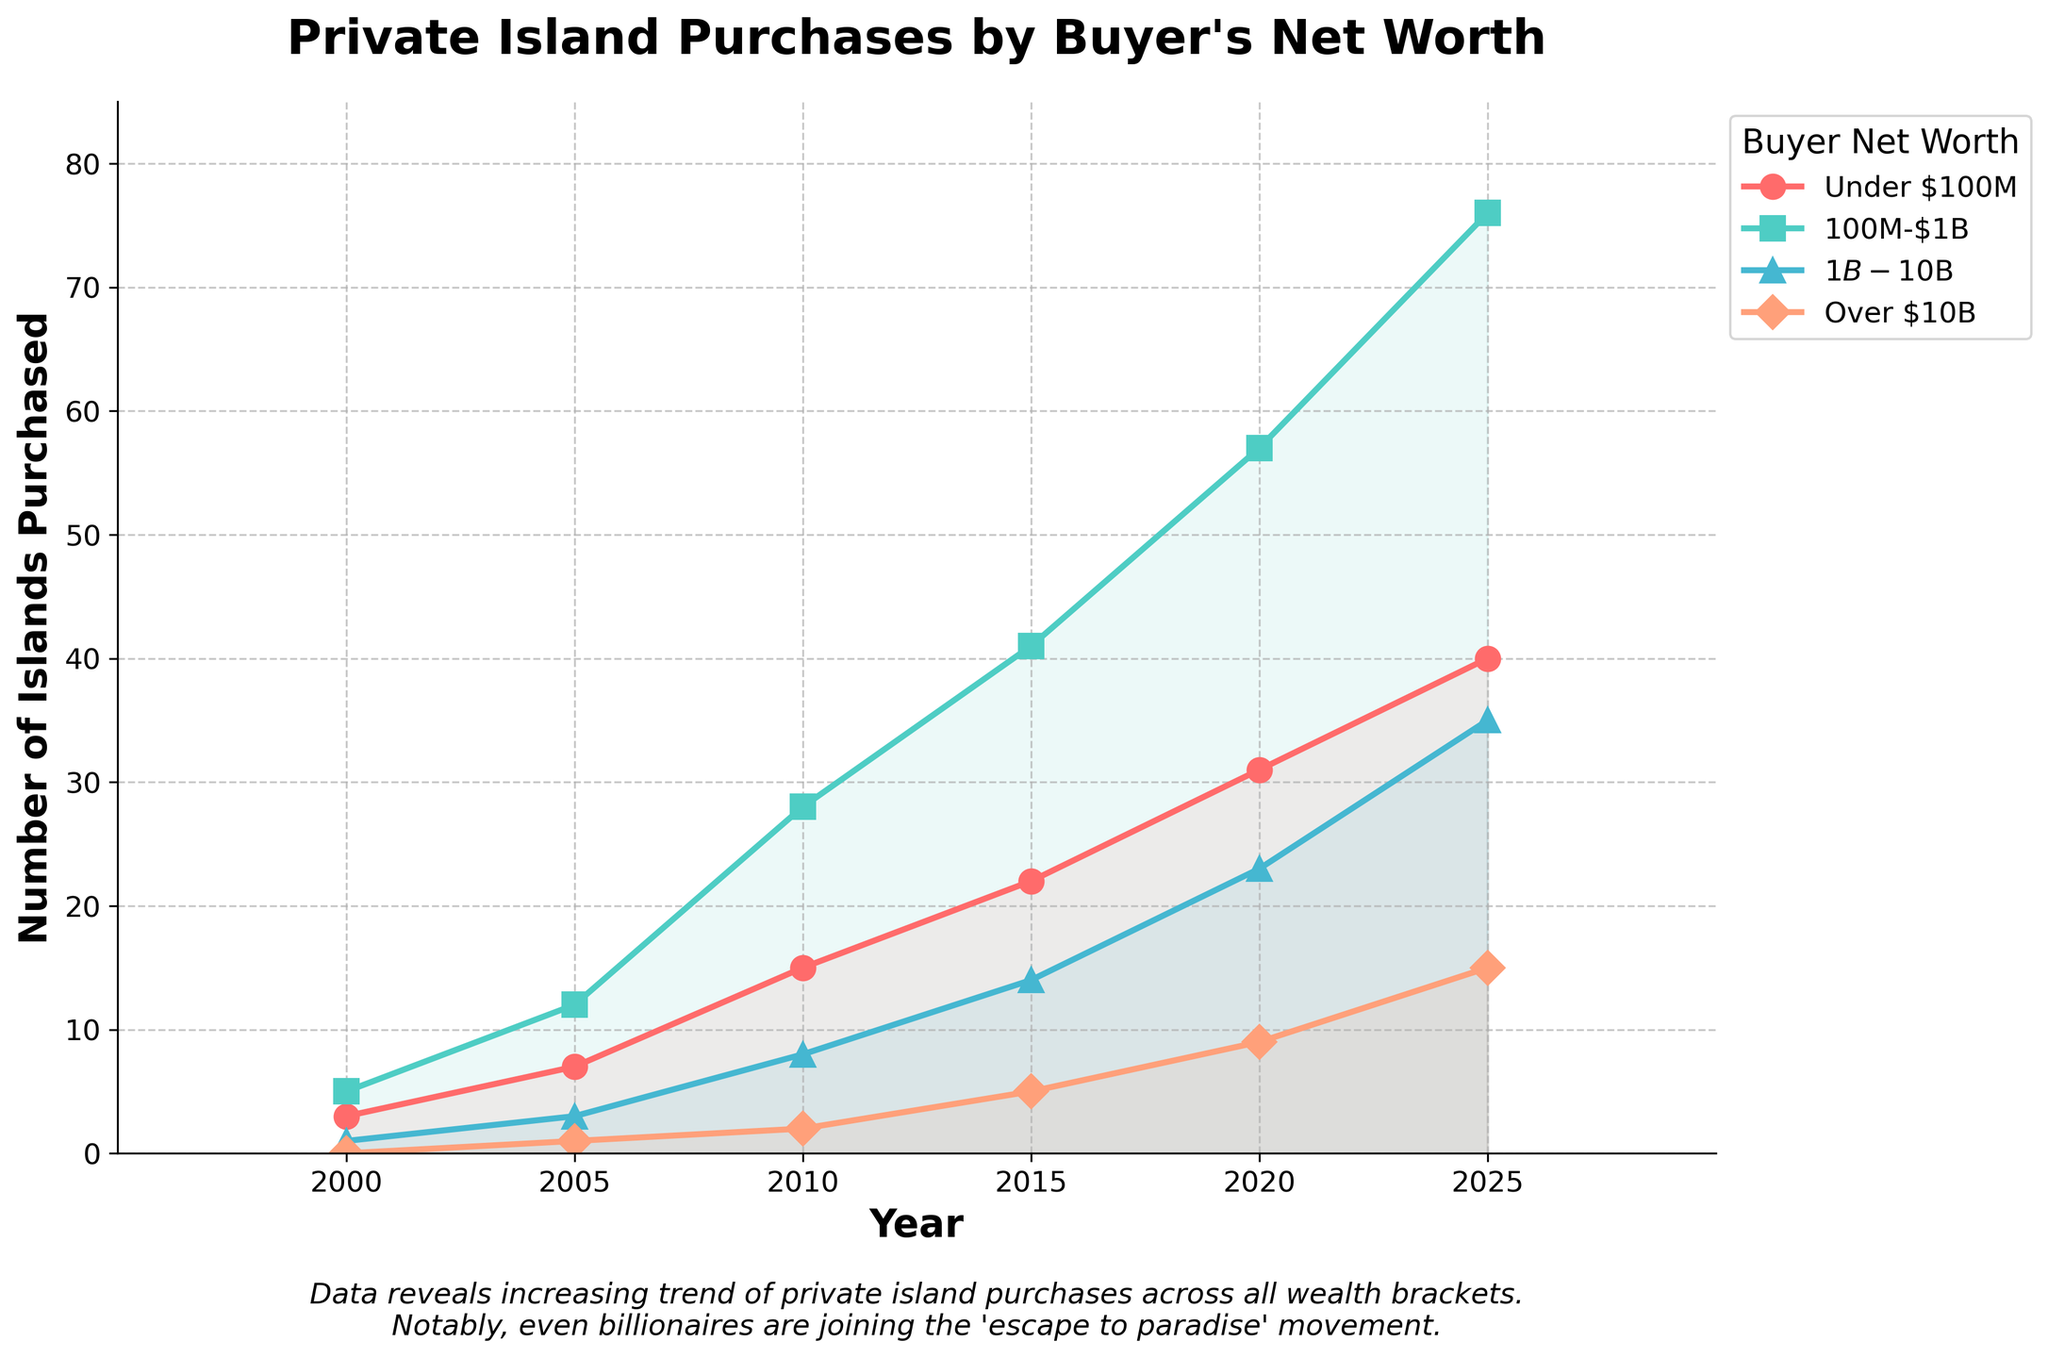How many islands were purchased by buyers with net worth over $10B in 2010? Refer to the curve labeled "Over $10B" and find the value at the year 2010. The line chart shows 2 islands were purchased in 2010 for the "Over $10B" category.
Answer: 2 Which net worth category saw the greatest increase in the number of islands purchased from 2000 to 2025? Calculate the difference for each category from 2000 to 2025. For "Under $100M": 40 - 3 = 37, for "$100M-$1B": 76 - 5 = 71, for "$1B-$10B": 35 - 1 = 34, for "Over $10B": 15 - 0 = 15. The category "$100M-$1B" has the highest increase of 71 islands.
Answer: $100M-$1B How many total islands were purchased across all net worth categories in 2020? Sum the values from all categories for the year 2020: 31 (Under $100M) + 57 ($100M-$1B) + 23 ($1B-$10B) + 9 (Over $10B) = 120.
Answer: 120 Between which two consecutive years did buyers with net worth under $100M see the largest increase in island purchases? Compare the yearly increase for the "Under $100M" category: 2005-2000: 7-3=4, 2010-2005: 15-7=8, 2015-2010: 22-15=7, 2020-2015: 31-22=9, 2025-2020: 40-31=9. The largest increase occurred between 2010-2015 and 2020-2025 with an increase of 9 each.
Answer: 2015-2020 For buyers with net worth $1B-$10B, what is the average number of islands purchased per year during the period shown? Calculate the mean for "$1B-$10B" values: (1 + 3 + 8 + 14 + 23 + 35) / 6 = 84 / 6 = 14.
Answer: 14 In 2015, did buyers with net worth $100M-$1B purchase more or fewer islands than the combined total of buyers with net worth under $100M and buyers over $10B? Check the numbers for 2015: "$100M-$1B" is 41, "Under $100M" is 22, "Over $10B" is 5. Combined Under $100M and Over $10B is 22 + 5 = 27. Thus, "$100M-$1B" (41) > 27.
Answer: More How does the trend in island purchases for buyers over $10B from 2010 to 2025 compare to buyers between $1B-$10B? Look at the slopes of the lines from 2010 to 2025. "Over $10B" increases from 2 to 15, and "$1B-$10B" increases from 8 to 35. Both trends are upward but the slope for "$1B-$10B" is steeper, indicating a faster rate of increase.
Answer: Faster for $1B-$10B Which category consistently purchased the fewest islands each year from 2000 to 2025? Observe the lowest line in each year: consistently, "Over $10B" category has the fewest islands purchased every year.
Answer: Over $10B 